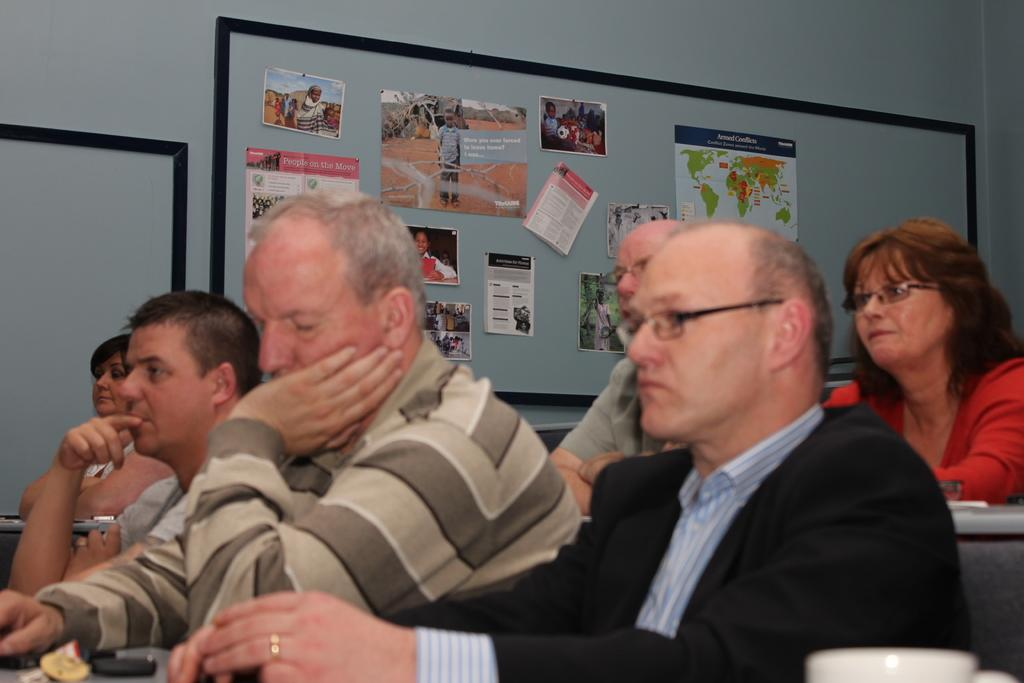What are the people in the image doing? The people in the image are seated. What is on the table in the image? There is a table with paper on it in the image. Can you describe the appearance of some people in the image? Some people in the image are wearing spectacles. What can be seen on the board in the image? There are posters on a board in the image. What else can be seen on a board in the image? There is another board visible in the image. What type of pan is being used to cook food in the image? There is no pan or cooking activity present in the image. How many carriages are visible in the image? There are no carriages present in the image. 